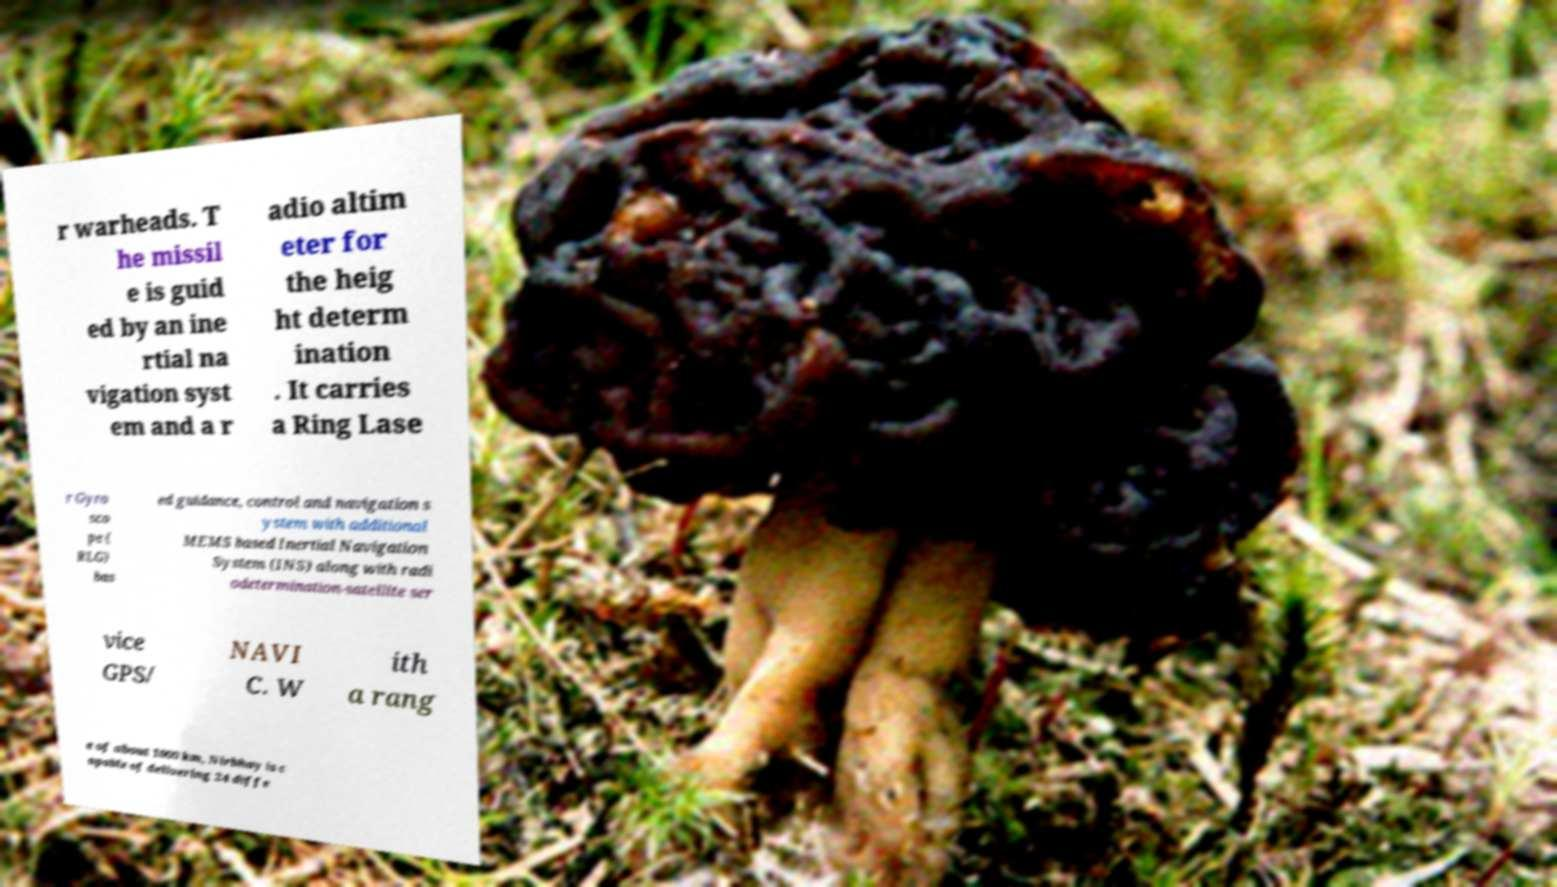For documentation purposes, I need the text within this image transcribed. Could you provide that? r warheads. T he missil e is guid ed by an ine rtial na vigation syst em and a r adio altim eter for the heig ht determ ination . It carries a Ring Lase r Gyro sco pe ( RLG) bas ed guidance, control and navigation s ystem with additional MEMS based Inertial Navigation System (INS) along with radi odetermination-satellite ser vice GPS/ NAVI C. W ith a rang e of about 1000 km, Nirbhay is c apable of delivering 24 diffe 